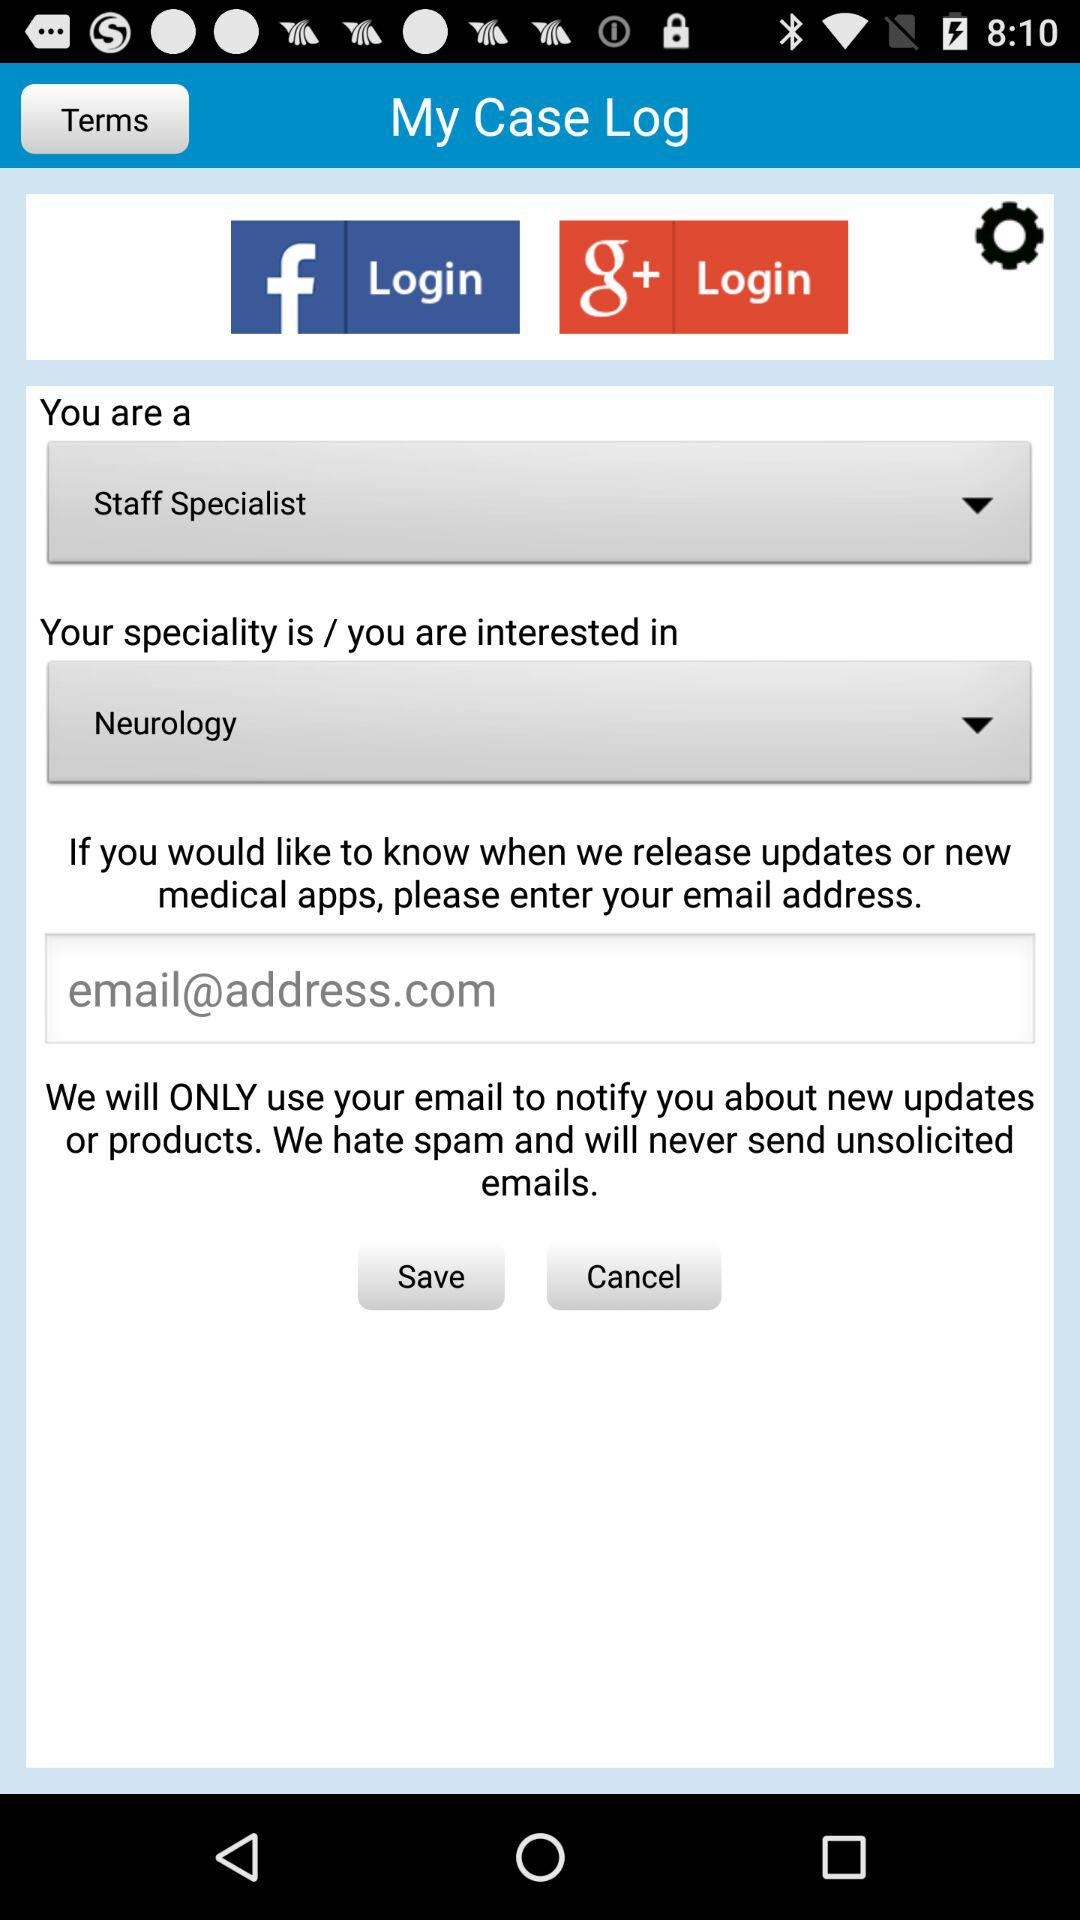What are the different options available for logging in? The available options are "Facebook" and "Google+". 